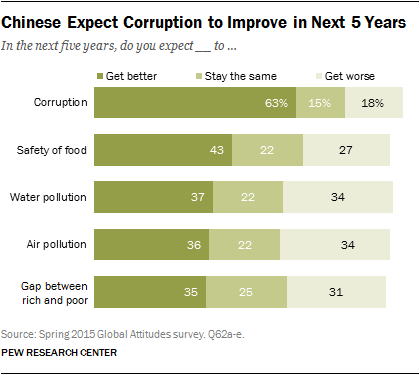Point out several critical features in this image. The color of the 'Get Better Bars' is dark green. The difference in the value of the largest green bar and the largest grey bar is 29. 